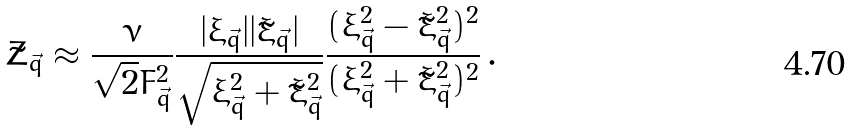<formula> <loc_0><loc_0><loc_500><loc_500>\tilde { Z } _ { \vec { q } } \approx \frac { \nu } { \sqrt { 2 } F _ { \vec { q } } ^ { 2 } } \frac { | \xi _ { \vec { q } } | | \tilde { \xi } _ { \vec { q } } | } { \sqrt { \xi _ { \vec { q } } ^ { 2 } + \tilde { \xi } _ { \vec { q } } ^ { 2 } } } \frac { ( \xi _ { \vec { q } } ^ { 2 } - \tilde { \xi } _ { \vec { q } } ^ { 2 } ) ^ { 2 } } { ( \xi _ { \vec { q } } ^ { 2 } + \tilde { \xi } _ { \vec { q } } ^ { 2 } ) ^ { 2 } } \, .</formula> 